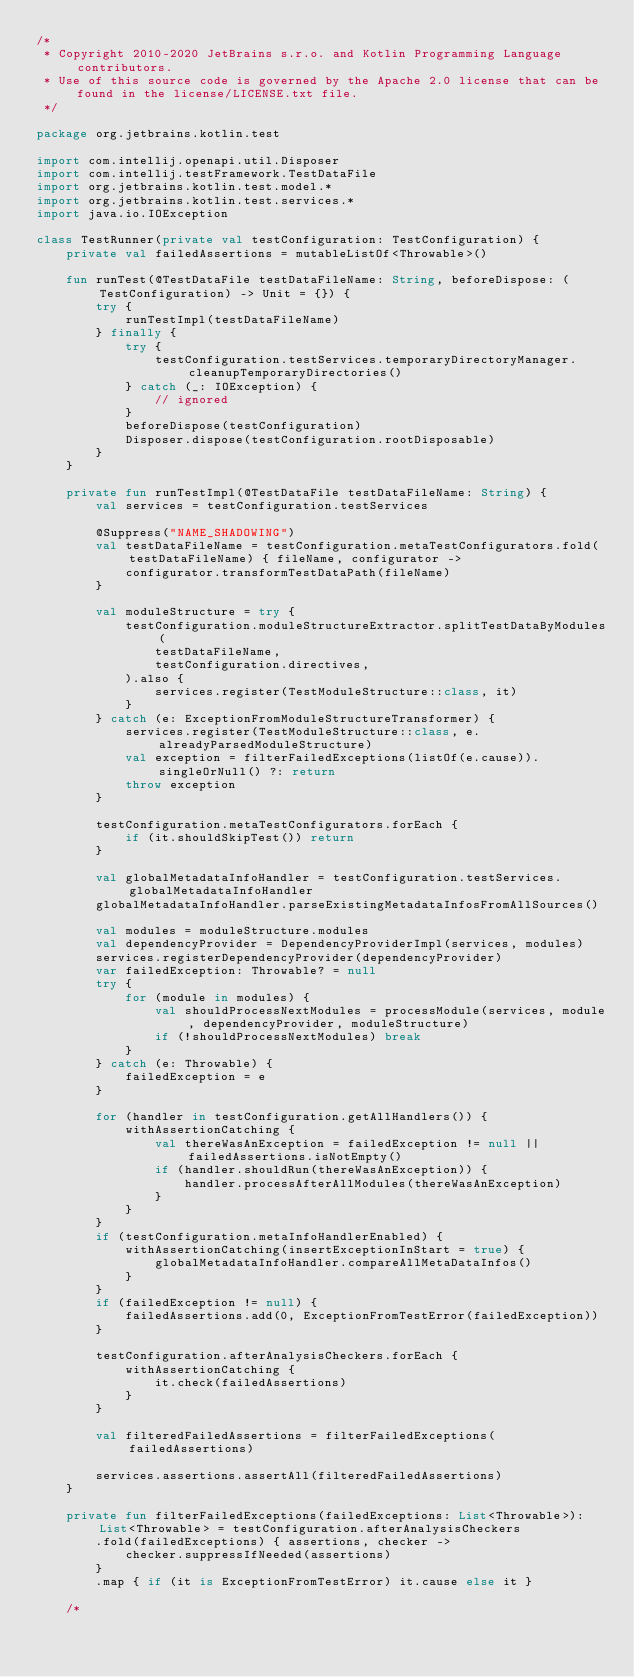Convert code to text. <code><loc_0><loc_0><loc_500><loc_500><_Kotlin_>/*
 * Copyright 2010-2020 JetBrains s.r.o. and Kotlin Programming Language contributors.
 * Use of this source code is governed by the Apache 2.0 license that can be found in the license/LICENSE.txt file.
 */

package org.jetbrains.kotlin.test

import com.intellij.openapi.util.Disposer
import com.intellij.testFramework.TestDataFile
import org.jetbrains.kotlin.test.model.*
import org.jetbrains.kotlin.test.services.*
import java.io.IOException

class TestRunner(private val testConfiguration: TestConfiguration) {
    private val failedAssertions = mutableListOf<Throwable>()

    fun runTest(@TestDataFile testDataFileName: String, beforeDispose: (TestConfiguration) -> Unit = {}) {
        try {
            runTestImpl(testDataFileName)
        } finally {
            try {
                testConfiguration.testServices.temporaryDirectoryManager.cleanupTemporaryDirectories()
            } catch (_: IOException) {
                // ignored
            }
            beforeDispose(testConfiguration)
            Disposer.dispose(testConfiguration.rootDisposable)
        }
    }

    private fun runTestImpl(@TestDataFile testDataFileName: String) {
        val services = testConfiguration.testServices

        @Suppress("NAME_SHADOWING")
        val testDataFileName = testConfiguration.metaTestConfigurators.fold(testDataFileName) { fileName, configurator ->
            configurator.transformTestDataPath(fileName)
        }

        val moduleStructure = try {
            testConfiguration.moduleStructureExtractor.splitTestDataByModules(
                testDataFileName,
                testConfiguration.directives,
            ).also {
                services.register(TestModuleStructure::class, it)
            }
        } catch (e: ExceptionFromModuleStructureTransformer) {
            services.register(TestModuleStructure::class, e.alreadyParsedModuleStructure)
            val exception = filterFailedExceptions(listOf(e.cause)).singleOrNull() ?: return
            throw exception
        }

        testConfiguration.metaTestConfigurators.forEach {
            if (it.shouldSkipTest()) return
        }

        val globalMetadataInfoHandler = testConfiguration.testServices.globalMetadataInfoHandler
        globalMetadataInfoHandler.parseExistingMetadataInfosFromAllSources()

        val modules = moduleStructure.modules
        val dependencyProvider = DependencyProviderImpl(services, modules)
        services.registerDependencyProvider(dependencyProvider)
        var failedException: Throwable? = null
        try {
            for (module in modules) {
                val shouldProcessNextModules = processModule(services, module, dependencyProvider, moduleStructure)
                if (!shouldProcessNextModules) break
            }
        } catch (e: Throwable) {
            failedException = e
        }

        for (handler in testConfiguration.getAllHandlers()) {
            withAssertionCatching {
                val thereWasAnException = failedException != null || failedAssertions.isNotEmpty()
                if (handler.shouldRun(thereWasAnException)) {
                    handler.processAfterAllModules(thereWasAnException)
                }
            }
        }
        if (testConfiguration.metaInfoHandlerEnabled) {
            withAssertionCatching(insertExceptionInStart = true) {
                globalMetadataInfoHandler.compareAllMetaDataInfos()
            }
        }
        if (failedException != null) {
            failedAssertions.add(0, ExceptionFromTestError(failedException))
        }

        testConfiguration.afterAnalysisCheckers.forEach {
            withAssertionCatching {
                it.check(failedAssertions)
            }
        }

        val filteredFailedAssertions = filterFailedExceptions(failedAssertions)

        services.assertions.assertAll(filteredFailedAssertions)
    }

    private fun filterFailedExceptions(failedExceptions: List<Throwable>): List<Throwable> = testConfiguration.afterAnalysisCheckers
        .fold(failedExceptions) { assertions, checker ->
            checker.suppressIfNeeded(assertions)
        }
        .map { if (it is ExceptionFromTestError) it.cause else it }

    /*</code> 